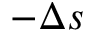Convert formula to latex. <formula><loc_0><loc_0><loc_500><loc_500>- \Delta s</formula> 